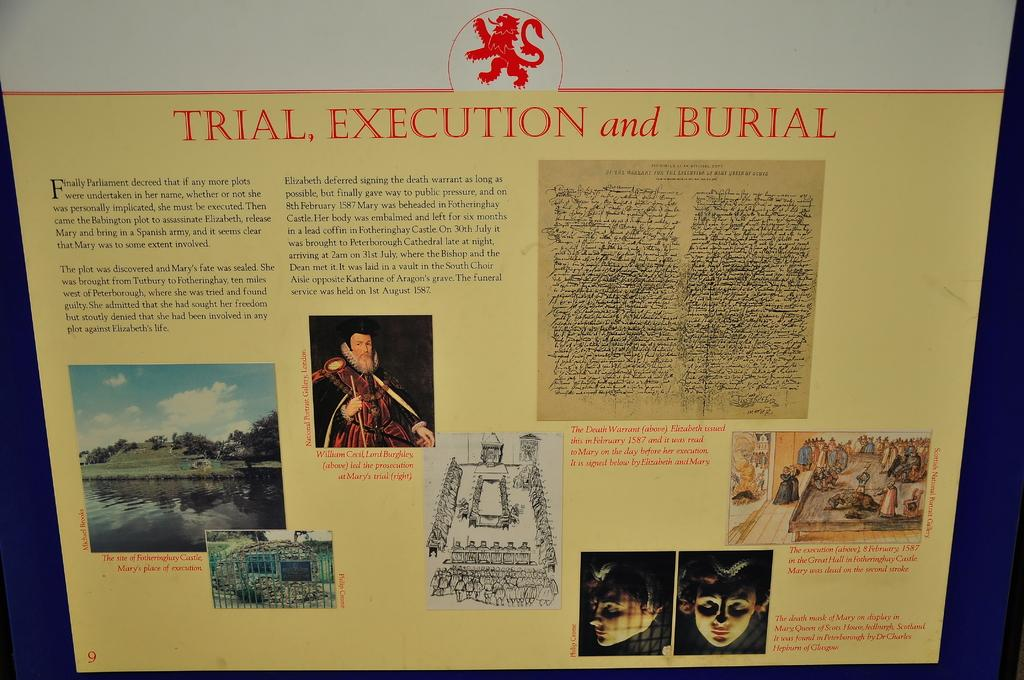<image>
Write a terse but informative summary of the picture. Trial, Execution and Burial writing and pictures with a red lion symbol at top. 